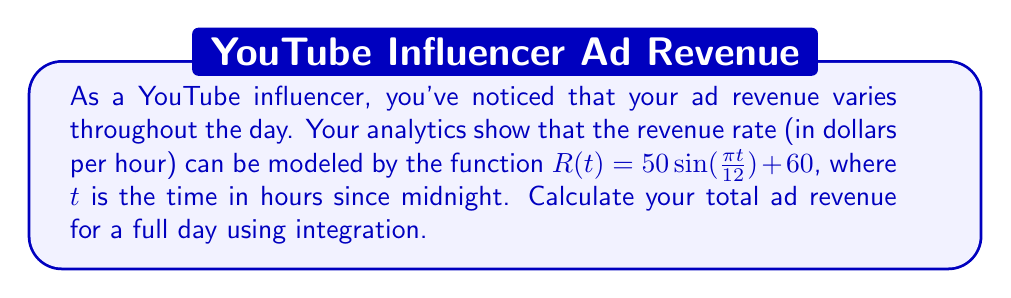Teach me how to tackle this problem. To solve this problem, we need to integrate the revenue rate function over a 24-hour period. Here's how we can approach it:

1) The revenue rate function is given as:
   $R(t) = 50 \sin(\frac{\pi t}{12}) + 60$

2) To find the total revenue, we need to integrate this function from $t=0$ to $t=24$:
   $$\text{Total Revenue} = \int_0^{24} R(t) dt = \int_0^{24} (50 \sin(\frac{\pi t}{12}) + 60) dt$$

3) Let's split this into two integrals:
   $$\int_0^{24} 50 \sin(\frac{\pi t}{12}) dt + \int_0^{24} 60 dt$$

4) For the first integral, we can use the substitution $u = \frac{\pi t}{12}$:
   $$50 \cdot \frac{12}{\pi} \int_0^{2\pi} \sin(u) du = -\frac{600}{\pi} [\cos(u)]_0^{2\pi} = -\frac{600}{\pi} (\cos(2\pi) - \cos(0)) = 0$$

5) The second integral is straightforward:
   $$\int_0^{24} 60 dt = 60t \Big|_0^{24} = 60 \cdot 24 = 1440$$

6) Adding the results from steps 4 and 5:
   $$\text{Total Revenue} = 0 + 1440 = 1440$$

Therefore, the total ad revenue for a full day is $1440.
Answer: $1440 